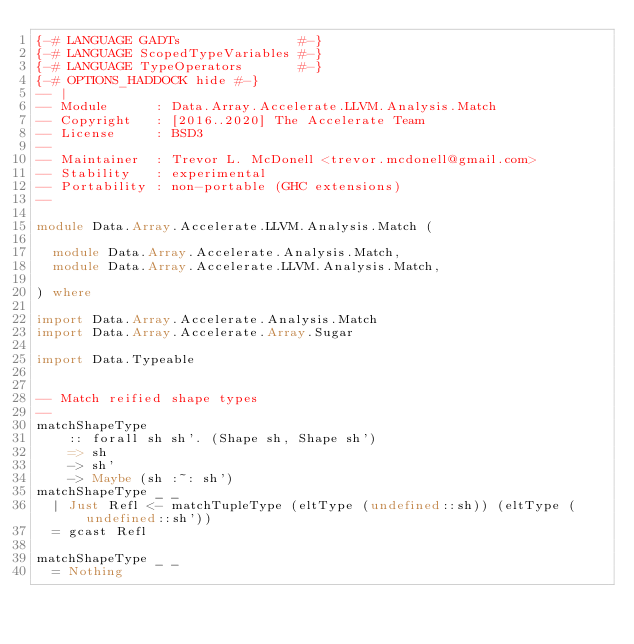<code> <loc_0><loc_0><loc_500><loc_500><_Haskell_>{-# LANGUAGE GADTs               #-}
{-# LANGUAGE ScopedTypeVariables #-}
{-# LANGUAGE TypeOperators       #-}
{-# OPTIONS_HADDOCK hide #-}
-- |
-- Module      : Data.Array.Accelerate.LLVM.Analysis.Match
-- Copyright   : [2016..2020] The Accelerate Team
-- License     : BSD3
--
-- Maintainer  : Trevor L. McDonell <trevor.mcdonell@gmail.com>
-- Stability   : experimental
-- Portability : non-portable (GHC extensions)
--

module Data.Array.Accelerate.LLVM.Analysis.Match (

  module Data.Array.Accelerate.Analysis.Match,
  module Data.Array.Accelerate.LLVM.Analysis.Match,

) where

import Data.Array.Accelerate.Analysis.Match
import Data.Array.Accelerate.Array.Sugar

import Data.Typeable


-- Match reified shape types
--
matchShapeType
    :: forall sh sh'. (Shape sh, Shape sh')
    => sh
    -> sh'
    -> Maybe (sh :~: sh')
matchShapeType _ _
  | Just Refl <- matchTupleType (eltType (undefined::sh)) (eltType (undefined::sh'))
  = gcast Refl

matchShapeType _ _
  = Nothing

</code> 